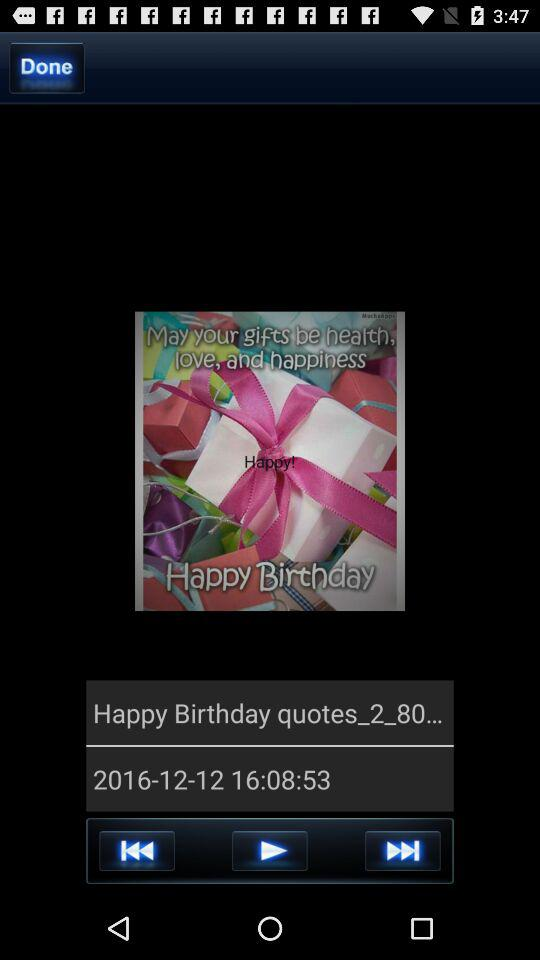Whose birthday is it?
When the provided information is insufficient, respond with <no answer>. <no answer> 